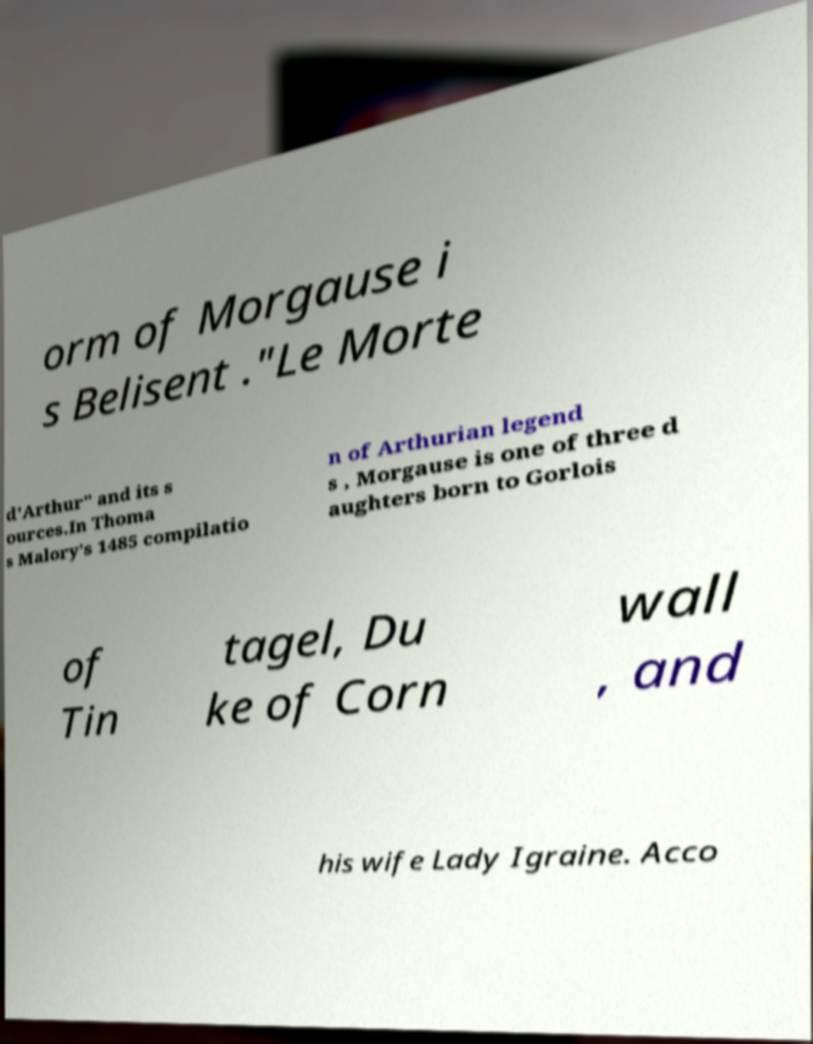Please identify and transcribe the text found in this image. orm of Morgause i s Belisent ."Le Morte d'Arthur" and its s ources.In Thoma s Malory's 1485 compilatio n of Arthurian legend s , Morgause is one of three d aughters born to Gorlois of Tin tagel, Du ke of Corn wall , and his wife Lady Igraine. Acco 